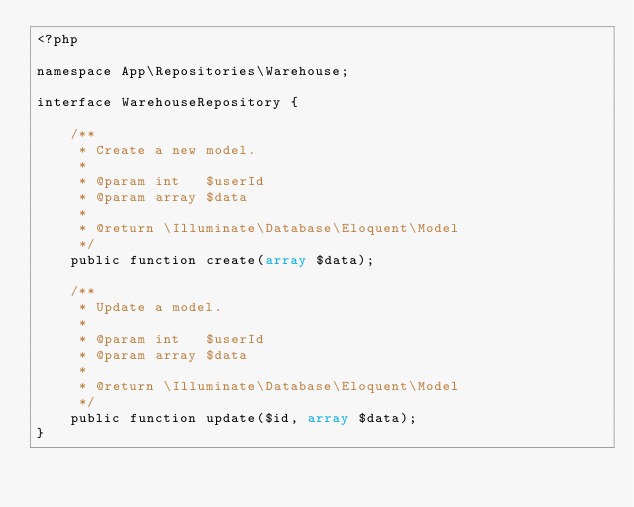Convert code to text. <code><loc_0><loc_0><loc_500><loc_500><_PHP_><?php

namespace App\Repositories\Warehouse;

interface WarehouseRepository {

    /**
     * Create a new model.
     *
     * @param int   $userId
     * @param array $data
     *
     * @return \Illuminate\Database\Eloquent\Model
     */
    public function create(array $data);

    /**
     * Update a model.
     *
     * @param int   $userId
     * @param array $data
     *
     * @return \Illuminate\Database\Eloquent\Model
     */
    public function update($id, array $data);
}
</code> 